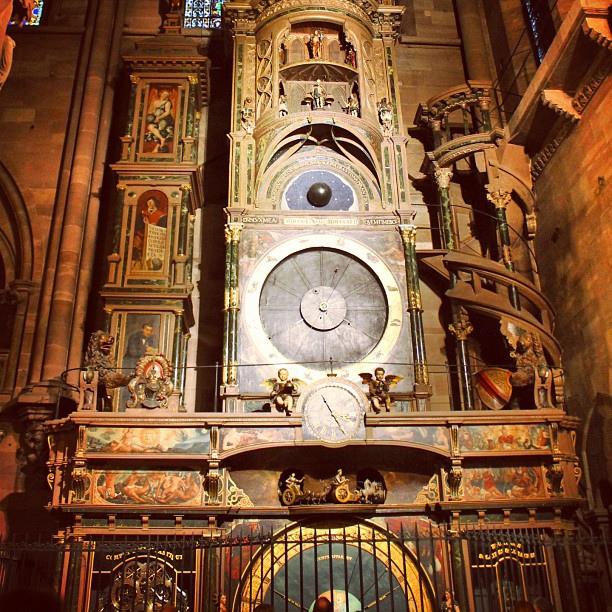What is the main color of this article?
Write a very short answer. Brown. Can you see a clock in the picture?
Write a very short answer. Yes. Is this the interior of a church?
Short answer required. Yes. 